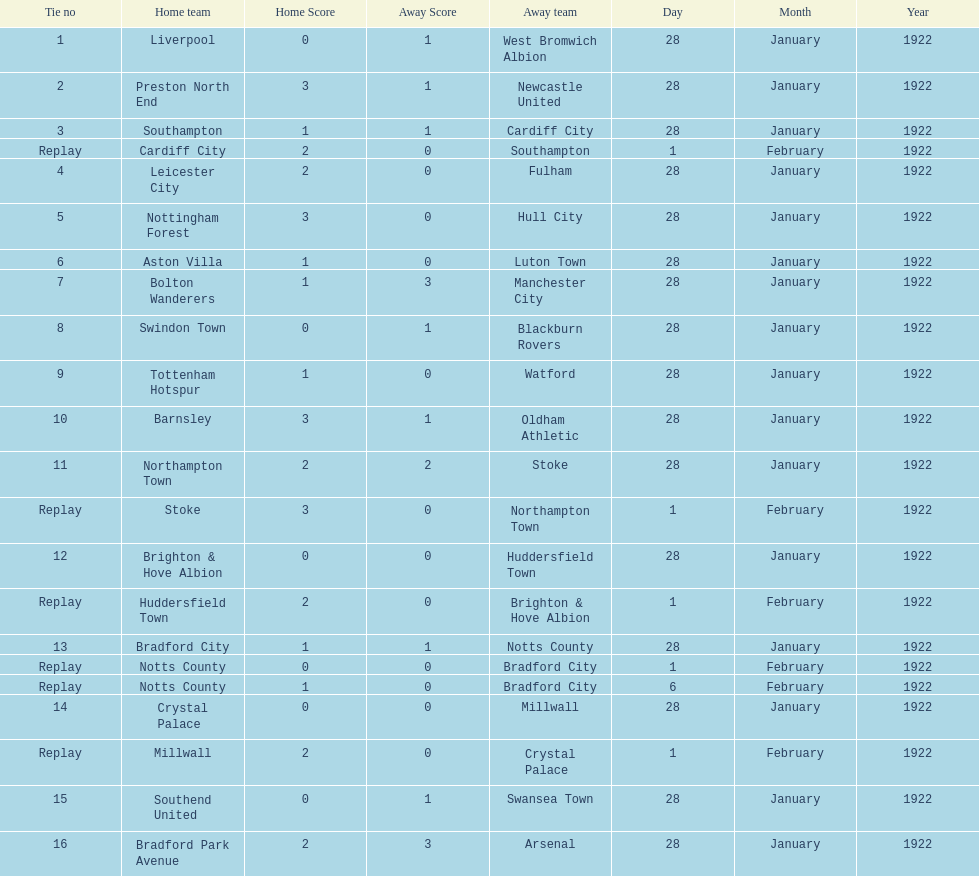Which game had a higher total number of goals scored, 1 or 16? 16. 